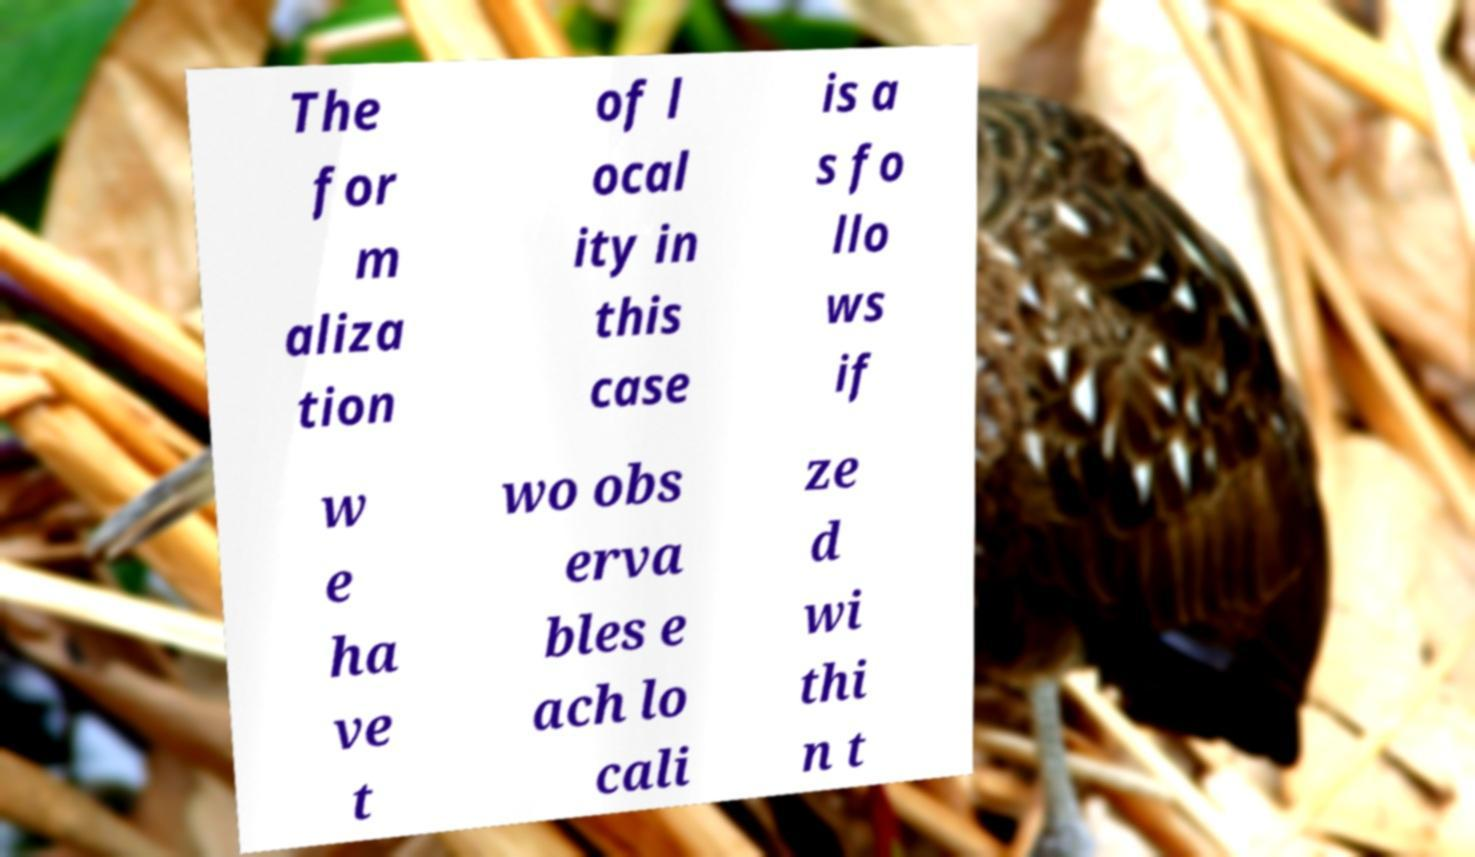Can you read and provide the text displayed in the image?This photo seems to have some interesting text. Can you extract and type it out for me? The for m aliza tion of l ocal ity in this case is a s fo llo ws if w e ha ve t wo obs erva bles e ach lo cali ze d wi thi n t 